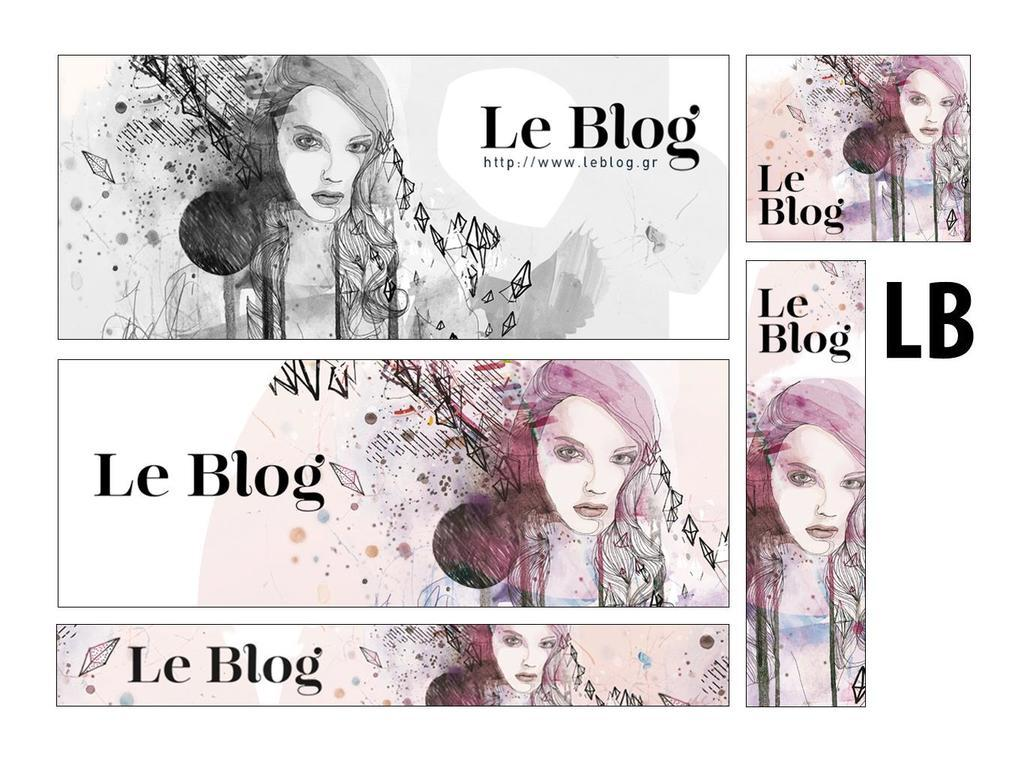What type of image is being described? The image is a collage. What can be seen within the collage? There is animation of a person's face in the image. Are there any words or phrases associated with the images in the collage? Yes, there is text associated with each image in the collage. What type of frame is used to display the collage? There is no information provided about a frame, so we cannot determine the type of frame used to display the collage. How much profit does the collage generate? The image is not a commercial product, so there is no information about profit associated with the collage. 